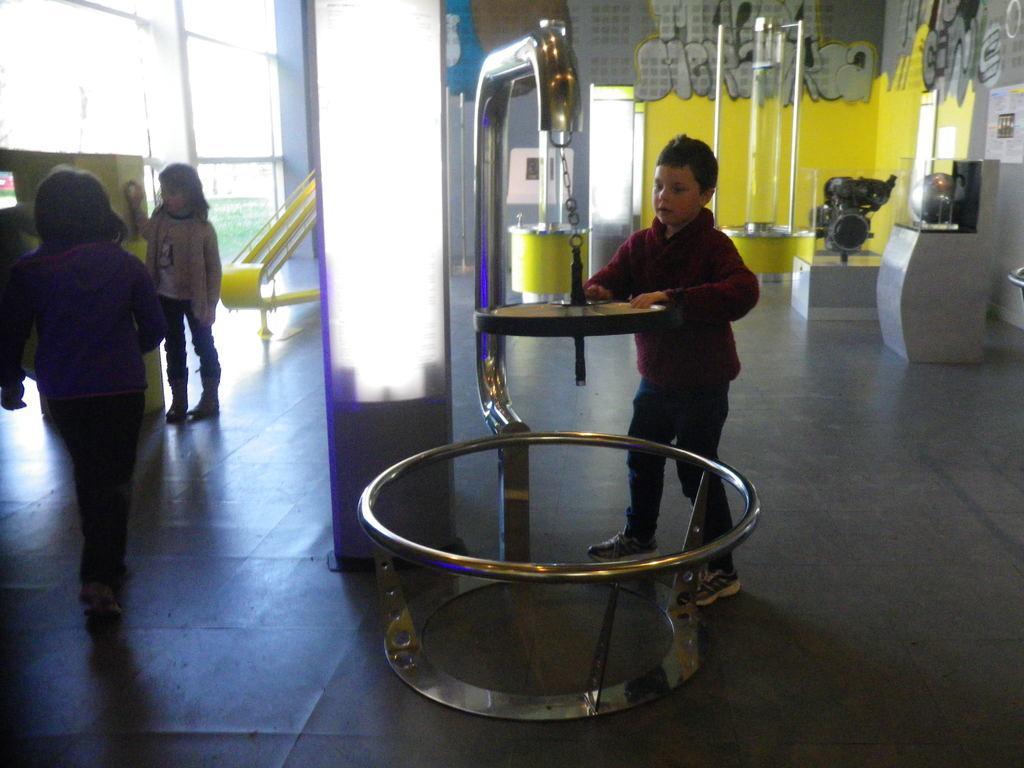Please provide a concise description of this image. This is an inside view of a building and here we can see a boy holding a machine and in the background, there are some other people and we can see some more machines and there is a wall. At the bottom, there is floor. 